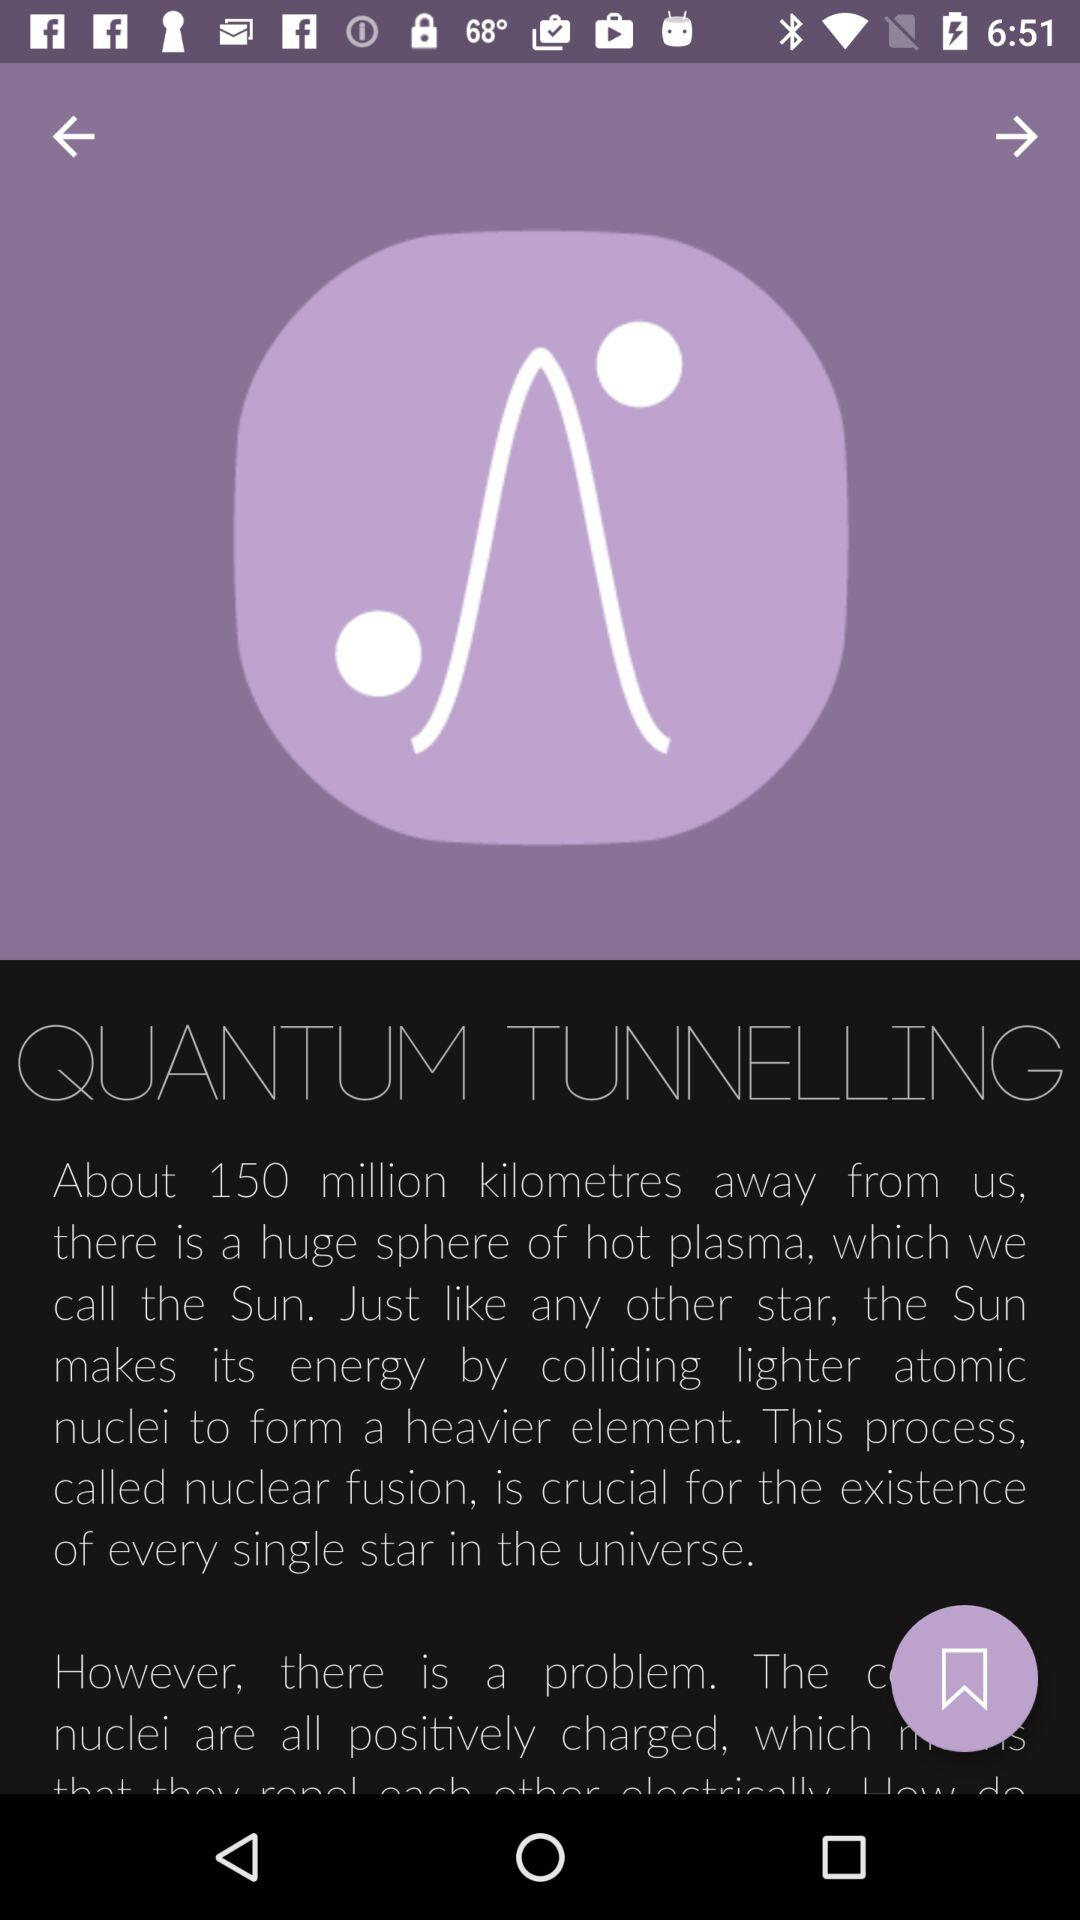How many items can be bookmarked in total?
When the provided information is insufficient, respond with <no answer>. <no answer> 